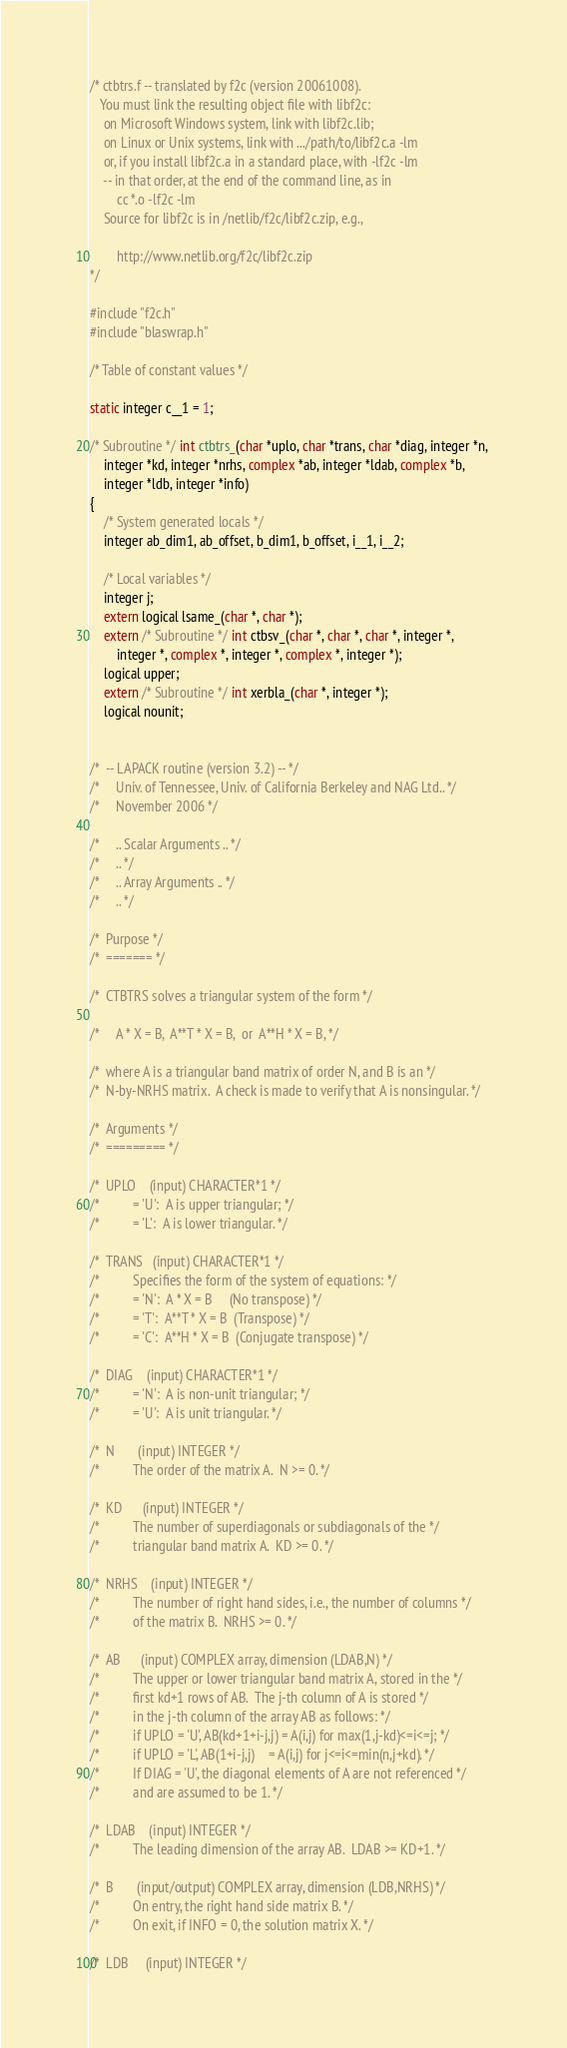Convert code to text. <code><loc_0><loc_0><loc_500><loc_500><_C_>/* ctbtrs.f -- translated by f2c (version 20061008).
   You must link the resulting object file with libf2c:
	on Microsoft Windows system, link with libf2c.lib;
	on Linux or Unix systems, link with .../path/to/libf2c.a -lm
	or, if you install libf2c.a in a standard place, with -lf2c -lm
	-- in that order, at the end of the command line, as in
		cc *.o -lf2c -lm
	Source for libf2c is in /netlib/f2c/libf2c.zip, e.g.,

		http://www.netlib.org/f2c/libf2c.zip
*/

#include "f2c.h"
#include "blaswrap.h"

/* Table of constant values */

static integer c__1 = 1;

/* Subroutine */ int ctbtrs_(char *uplo, char *trans, char *diag, integer *n, 
	integer *kd, integer *nrhs, complex *ab, integer *ldab, complex *b, 
	integer *ldb, integer *info)
{
    /* System generated locals */
    integer ab_dim1, ab_offset, b_dim1, b_offset, i__1, i__2;

    /* Local variables */
    integer j;
    extern logical lsame_(char *, char *);
    extern /* Subroutine */ int ctbsv_(char *, char *, char *, integer *, 
	    integer *, complex *, integer *, complex *, integer *);
    logical upper;
    extern /* Subroutine */ int xerbla_(char *, integer *);
    logical nounit;


/*  -- LAPACK routine (version 3.2) -- */
/*     Univ. of Tennessee, Univ. of California Berkeley and NAG Ltd.. */
/*     November 2006 */

/*     .. Scalar Arguments .. */
/*     .. */
/*     .. Array Arguments .. */
/*     .. */

/*  Purpose */
/*  ======= */

/*  CTBTRS solves a triangular system of the form */

/*     A * X = B,  A**T * X = B,  or  A**H * X = B, */

/*  where A is a triangular band matrix of order N, and B is an */
/*  N-by-NRHS matrix.  A check is made to verify that A is nonsingular. */

/*  Arguments */
/*  ========= */

/*  UPLO    (input) CHARACTER*1 */
/*          = 'U':  A is upper triangular; */
/*          = 'L':  A is lower triangular. */

/*  TRANS   (input) CHARACTER*1 */
/*          Specifies the form of the system of equations: */
/*          = 'N':  A * X = B     (No transpose) */
/*          = 'T':  A**T * X = B  (Transpose) */
/*          = 'C':  A**H * X = B  (Conjugate transpose) */

/*  DIAG    (input) CHARACTER*1 */
/*          = 'N':  A is non-unit triangular; */
/*          = 'U':  A is unit triangular. */

/*  N       (input) INTEGER */
/*          The order of the matrix A.  N >= 0. */

/*  KD      (input) INTEGER */
/*          The number of superdiagonals or subdiagonals of the */
/*          triangular band matrix A.  KD >= 0. */

/*  NRHS    (input) INTEGER */
/*          The number of right hand sides, i.e., the number of columns */
/*          of the matrix B.  NRHS >= 0. */

/*  AB      (input) COMPLEX array, dimension (LDAB,N) */
/*          The upper or lower triangular band matrix A, stored in the */
/*          first kd+1 rows of AB.  The j-th column of A is stored */
/*          in the j-th column of the array AB as follows: */
/*          if UPLO = 'U', AB(kd+1+i-j,j) = A(i,j) for max(1,j-kd)<=i<=j; */
/*          if UPLO = 'L', AB(1+i-j,j)    = A(i,j) for j<=i<=min(n,j+kd). */
/*          If DIAG = 'U', the diagonal elements of A are not referenced */
/*          and are assumed to be 1. */

/*  LDAB    (input) INTEGER */
/*          The leading dimension of the array AB.  LDAB >= KD+1. */

/*  B       (input/output) COMPLEX array, dimension (LDB,NRHS) */
/*          On entry, the right hand side matrix B. */
/*          On exit, if INFO = 0, the solution matrix X. */

/*  LDB     (input) INTEGER */</code> 